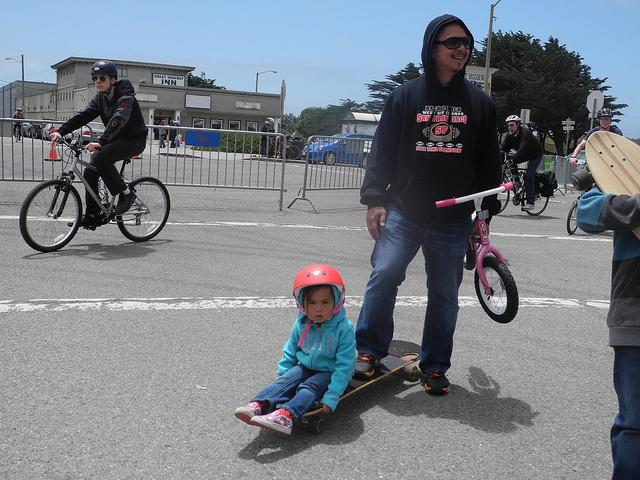Why is the child on the skateboard wearing a helmet?

Choices:
A) protection
B) fashion
C) punishment
D) camouflage protection 